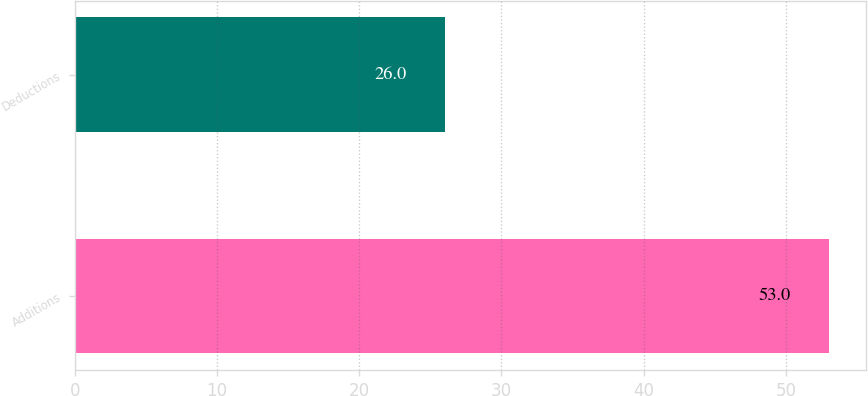Convert chart to OTSL. <chart><loc_0><loc_0><loc_500><loc_500><bar_chart><fcel>Additions<fcel>Deductions<nl><fcel>53<fcel>26<nl></chart> 